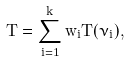<formula> <loc_0><loc_0><loc_500><loc_500>T = \sum _ { i = 1 } ^ { k } w _ { i } T ( \nu _ { i } ) ,</formula> 